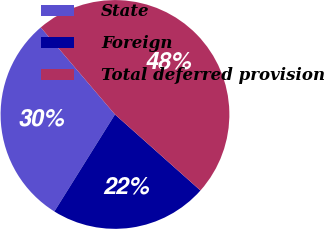<chart> <loc_0><loc_0><loc_500><loc_500><pie_chart><fcel>State<fcel>Foreign<fcel>Total deferred provision<nl><fcel>29.87%<fcel>22.32%<fcel>47.81%<nl></chart> 